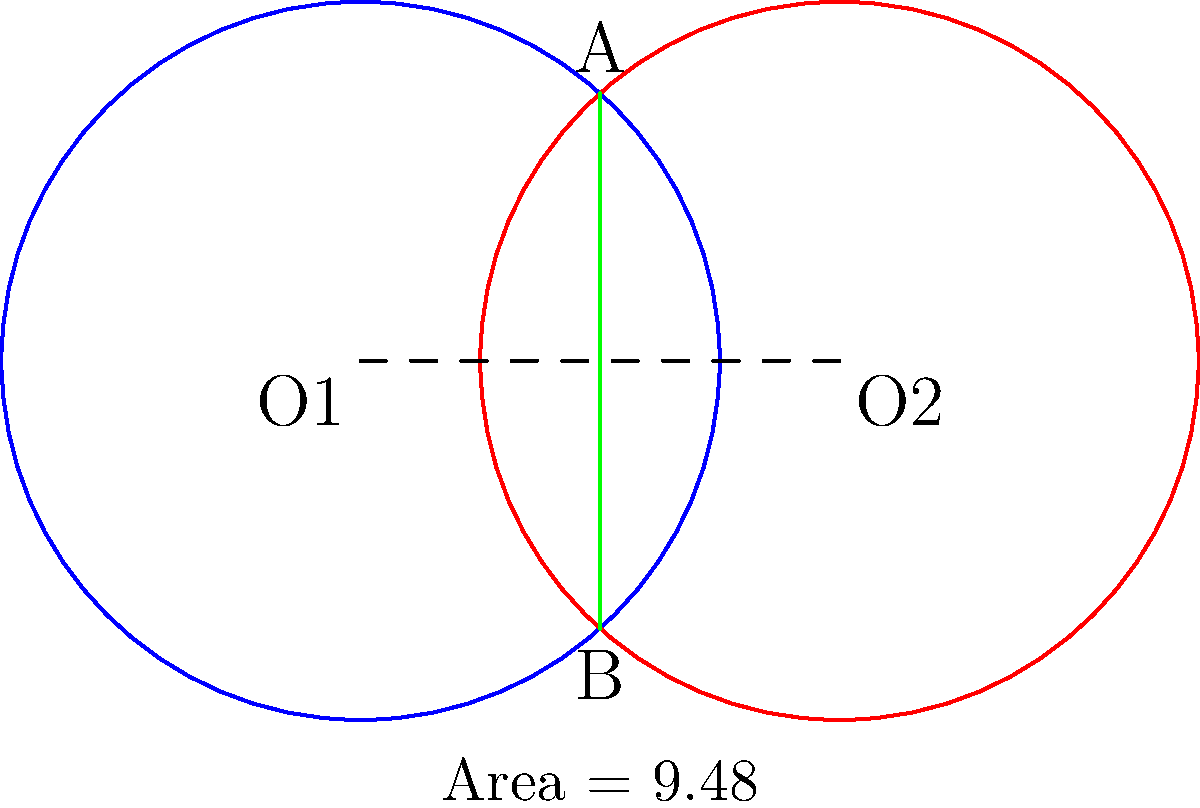Two market demographics for your news network are represented by overlapping circles, each with a radius of 3 units. The centers of these circles are 4 units apart. Calculate the area of the overlapping region (shaded green) to determine the size of the shared audience. Round your answer to two decimal places. To solve this problem, we'll follow these steps:

1) First, we need to find the angle of the circular sector in one circle. We can do this using the formula:

   $$\cos(\theta/2) = \frac{d}{2r}$$

   Where $d$ is the distance between centers, and $r$ is the radius.

2) Plugging in our values:

   $$\cos(\theta/2) = \frac{4}{2(3)} = \frac{2}{3}$$

3) Taking the inverse cosine (arccos) of both sides:

   $$\theta/2 = \arccos(\frac{2}{3})$$
   $$\theta = 2\arccos(\frac{2}{3})$$

4) The area of the circular sector is:

   $$A_{sector} = r^2 \theta = 3^2 \cdot 2\arccos(\frac{2}{3})$$

5) Now we need to subtract the area of the triangle formed by the radius and chord:

   $$A_{triangle} = \frac{1}{2} \cdot 3 \cdot 3 \sin(2\arccos(\frac{2}{3}))$$

6) The area of the overlap is twice the difference between these areas:

   $$A_{overlap} = 2(A_{sector} - A_{triangle})$$
   $$= 2(3^2 \cdot 2\arccos(\frac{2}{3}) - \frac{1}{2} \cdot 3 \cdot 3 \sin(2\arccos(\frac{2}{3})))$$
   $$= 18\arccos(\frac{2}{3}) - 9\sin(2\arccos(\frac{2}{3}))$$

7) Calculating this and rounding to two decimal places gives us 3.59 square units.
Answer: 3.59 square units 